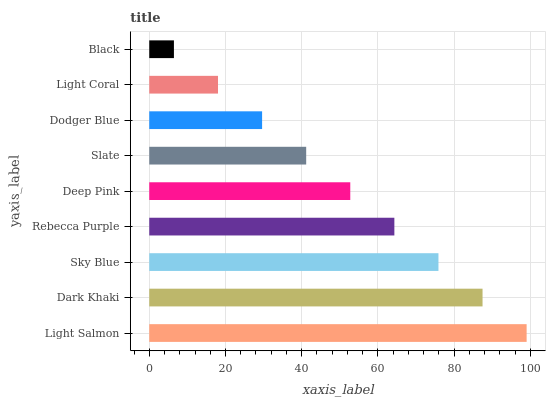Is Black the minimum?
Answer yes or no. Yes. Is Light Salmon the maximum?
Answer yes or no. Yes. Is Dark Khaki the minimum?
Answer yes or no. No. Is Dark Khaki the maximum?
Answer yes or no. No. Is Light Salmon greater than Dark Khaki?
Answer yes or no. Yes. Is Dark Khaki less than Light Salmon?
Answer yes or no. Yes. Is Dark Khaki greater than Light Salmon?
Answer yes or no. No. Is Light Salmon less than Dark Khaki?
Answer yes or no. No. Is Deep Pink the high median?
Answer yes or no. Yes. Is Deep Pink the low median?
Answer yes or no. Yes. Is Rebecca Purple the high median?
Answer yes or no. No. Is Light Salmon the low median?
Answer yes or no. No. 